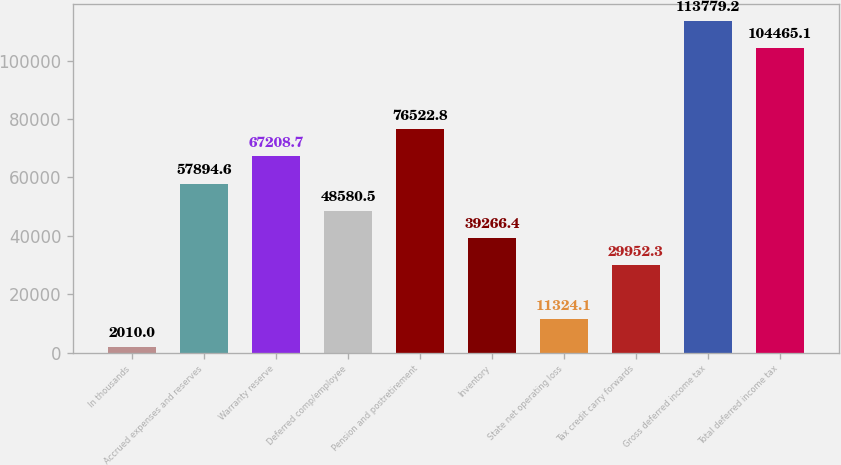Convert chart. <chart><loc_0><loc_0><loc_500><loc_500><bar_chart><fcel>In thousands<fcel>Accrued expenses and reserves<fcel>Warranty reserve<fcel>Deferred comp/employee<fcel>Pension and postretirement<fcel>Inventory<fcel>State net operating loss<fcel>Tax credit carry forwards<fcel>Gross deferred income tax<fcel>Total deferred income tax<nl><fcel>2010<fcel>57894.6<fcel>67208.7<fcel>48580.5<fcel>76522.8<fcel>39266.4<fcel>11324.1<fcel>29952.3<fcel>113779<fcel>104465<nl></chart> 